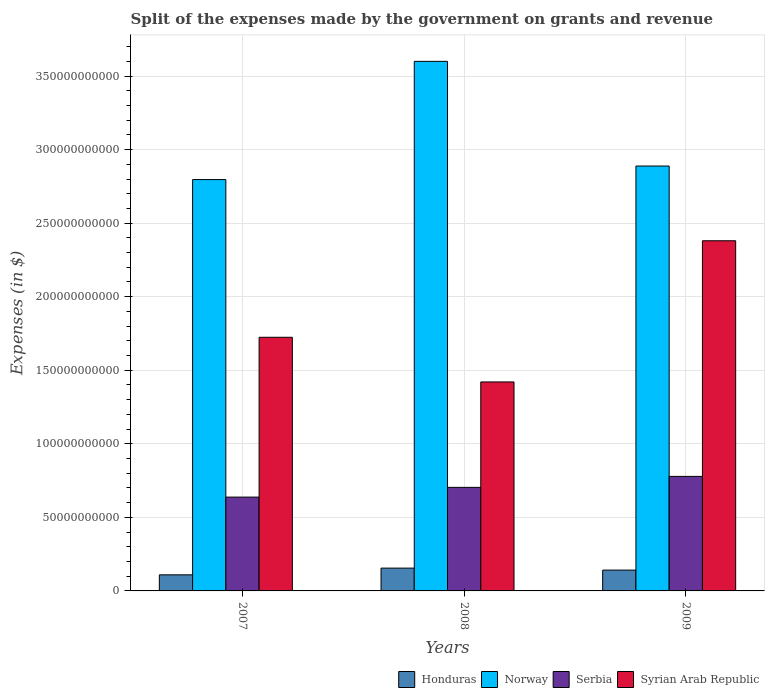How many different coloured bars are there?
Provide a short and direct response. 4. Are the number of bars per tick equal to the number of legend labels?
Give a very brief answer. Yes. Are the number of bars on each tick of the X-axis equal?
Give a very brief answer. Yes. What is the label of the 1st group of bars from the left?
Offer a very short reply. 2007. In how many cases, is the number of bars for a given year not equal to the number of legend labels?
Make the answer very short. 0. What is the expenses made by the government on grants and revenue in Serbia in 2009?
Your answer should be compact. 7.79e+1. Across all years, what is the maximum expenses made by the government on grants and revenue in Syrian Arab Republic?
Provide a short and direct response. 2.38e+11. Across all years, what is the minimum expenses made by the government on grants and revenue in Norway?
Keep it short and to the point. 2.80e+11. In which year was the expenses made by the government on grants and revenue in Serbia maximum?
Provide a succinct answer. 2009. In which year was the expenses made by the government on grants and revenue in Norway minimum?
Ensure brevity in your answer.  2007. What is the total expenses made by the government on grants and revenue in Norway in the graph?
Offer a very short reply. 9.28e+11. What is the difference between the expenses made by the government on grants and revenue in Syrian Arab Republic in 2008 and that in 2009?
Provide a succinct answer. -9.60e+1. What is the difference between the expenses made by the government on grants and revenue in Honduras in 2008 and the expenses made by the government on grants and revenue in Syrian Arab Republic in 2007?
Offer a very short reply. -1.57e+11. What is the average expenses made by the government on grants and revenue in Honduras per year?
Provide a succinct answer. 1.35e+1. In the year 2009, what is the difference between the expenses made by the government on grants and revenue in Serbia and expenses made by the government on grants and revenue in Norway?
Your response must be concise. -2.11e+11. In how many years, is the expenses made by the government on grants and revenue in Syrian Arab Republic greater than 170000000000 $?
Offer a terse response. 2. What is the ratio of the expenses made by the government on grants and revenue in Serbia in 2008 to that in 2009?
Offer a terse response. 0.9. What is the difference between the highest and the second highest expenses made by the government on grants and revenue in Syrian Arab Republic?
Your answer should be compact. 6.56e+1. What is the difference between the highest and the lowest expenses made by the government on grants and revenue in Honduras?
Offer a terse response. 4.57e+09. Is it the case that in every year, the sum of the expenses made by the government on grants and revenue in Norway and expenses made by the government on grants and revenue in Serbia is greater than the sum of expenses made by the government on grants and revenue in Syrian Arab Republic and expenses made by the government on grants and revenue in Honduras?
Offer a very short reply. No. What does the 4th bar from the left in 2009 represents?
Provide a succinct answer. Syrian Arab Republic. What does the 2nd bar from the right in 2007 represents?
Provide a short and direct response. Serbia. Is it the case that in every year, the sum of the expenses made by the government on grants and revenue in Serbia and expenses made by the government on grants and revenue in Norway is greater than the expenses made by the government on grants and revenue in Syrian Arab Republic?
Your answer should be compact. Yes. How many bars are there?
Ensure brevity in your answer.  12. Are all the bars in the graph horizontal?
Your response must be concise. No. What is the difference between two consecutive major ticks on the Y-axis?
Make the answer very short. 5.00e+1. Are the values on the major ticks of Y-axis written in scientific E-notation?
Your answer should be compact. No. Where does the legend appear in the graph?
Provide a succinct answer. Bottom right. How many legend labels are there?
Offer a terse response. 4. How are the legend labels stacked?
Keep it short and to the point. Horizontal. What is the title of the graph?
Make the answer very short. Split of the expenses made by the government on grants and revenue. What is the label or title of the X-axis?
Your answer should be very brief. Years. What is the label or title of the Y-axis?
Your answer should be very brief. Expenses (in $). What is the Expenses (in $) in Honduras in 2007?
Keep it short and to the point. 1.09e+1. What is the Expenses (in $) in Norway in 2007?
Your response must be concise. 2.80e+11. What is the Expenses (in $) of Serbia in 2007?
Your answer should be compact. 6.38e+1. What is the Expenses (in $) of Syrian Arab Republic in 2007?
Provide a succinct answer. 1.72e+11. What is the Expenses (in $) of Honduras in 2008?
Make the answer very short. 1.55e+1. What is the Expenses (in $) of Norway in 2008?
Your answer should be compact. 3.60e+11. What is the Expenses (in $) in Serbia in 2008?
Offer a very short reply. 7.04e+1. What is the Expenses (in $) in Syrian Arab Republic in 2008?
Your answer should be compact. 1.42e+11. What is the Expenses (in $) of Honduras in 2009?
Ensure brevity in your answer.  1.41e+1. What is the Expenses (in $) of Norway in 2009?
Your answer should be very brief. 2.89e+11. What is the Expenses (in $) of Serbia in 2009?
Ensure brevity in your answer.  7.79e+1. What is the Expenses (in $) of Syrian Arab Republic in 2009?
Your response must be concise. 2.38e+11. Across all years, what is the maximum Expenses (in $) of Honduras?
Your answer should be very brief. 1.55e+1. Across all years, what is the maximum Expenses (in $) in Norway?
Give a very brief answer. 3.60e+11. Across all years, what is the maximum Expenses (in $) of Serbia?
Your answer should be compact. 7.79e+1. Across all years, what is the maximum Expenses (in $) of Syrian Arab Republic?
Your answer should be very brief. 2.38e+11. Across all years, what is the minimum Expenses (in $) in Honduras?
Provide a succinct answer. 1.09e+1. Across all years, what is the minimum Expenses (in $) in Norway?
Your answer should be very brief. 2.80e+11. Across all years, what is the minimum Expenses (in $) in Serbia?
Ensure brevity in your answer.  6.38e+1. Across all years, what is the minimum Expenses (in $) of Syrian Arab Republic?
Provide a short and direct response. 1.42e+11. What is the total Expenses (in $) of Honduras in the graph?
Make the answer very short. 4.06e+1. What is the total Expenses (in $) in Norway in the graph?
Provide a short and direct response. 9.28e+11. What is the total Expenses (in $) in Serbia in the graph?
Your answer should be very brief. 2.12e+11. What is the total Expenses (in $) of Syrian Arab Republic in the graph?
Offer a very short reply. 5.52e+11. What is the difference between the Expenses (in $) of Honduras in 2007 and that in 2008?
Your answer should be very brief. -4.57e+09. What is the difference between the Expenses (in $) of Norway in 2007 and that in 2008?
Provide a succinct answer. -8.04e+1. What is the difference between the Expenses (in $) in Serbia in 2007 and that in 2008?
Give a very brief answer. -6.62e+09. What is the difference between the Expenses (in $) of Syrian Arab Republic in 2007 and that in 2008?
Offer a very short reply. 3.04e+1. What is the difference between the Expenses (in $) of Honduras in 2007 and that in 2009?
Your response must be concise. -3.22e+09. What is the difference between the Expenses (in $) of Norway in 2007 and that in 2009?
Offer a terse response. -9.20e+09. What is the difference between the Expenses (in $) in Serbia in 2007 and that in 2009?
Offer a terse response. -1.41e+1. What is the difference between the Expenses (in $) in Syrian Arab Republic in 2007 and that in 2009?
Offer a terse response. -6.56e+1. What is the difference between the Expenses (in $) of Honduras in 2008 and that in 2009?
Make the answer very short. 1.35e+09. What is the difference between the Expenses (in $) in Norway in 2008 and that in 2009?
Keep it short and to the point. 7.12e+1. What is the difference between the Expenses (in $) of Serbia in 2008 and that in 2009?
Your answer should be compact. -7.46e+09. What is the difference between the Expenses (in $) of Syrian Arab Republic in 2008 and that in 2009?
Your answer should be compact. -9.60e+1. What is the difference between the Expenses (in $) in Honduras in 2007 and the Expenses (in $) in Norway in 2008?
Your answer should be very brief. -3.49e+11. What is the difference between the Expenses (in $) of Honduras in 2007 and the Expenses (in $) of Serbia in 2008?
Provide a short and direct response. -5.95e+1. What is the difference between the Expenses (in $) in Honduras in 2007 and the Expenses (in $) in Syrian Arab Republic in 2008?
Your answer should be very brief. -1.31e+11. What is the difference between the Expenses (in $) of Norway in 2007 and the Expenses (in $) of Serbia in 2008?
Offer a terse response. 2.09e+11. What is the difference between the Expenses (in $) of Norway in 2007 and the Expenses (in $) of Syrian Arab Republic in 2008?
Keep it short and to the point. 1.38e+11. What is the difference between the Expenses (in $) of Serbia in 2007 and the Expenses (in $) of Syrian Arab Republic in 2008?
Offer a very short reply. -7.83e+1. What is the difference between the Expenses (in $) in Honduras in 2007 and the Expenses (in $) in Norway in 2009?
Offer a terse response. -2.78e+11. What is the difference between the Expenses (in $) in Honduras in 2007 and the Expenses (in $) in Serbia in 2009?
Your answer should be very brief. -6.69e+1. What is the difference between the Expenses (in $) of Honduras in 2007 and the Expenses (in $) of Syrian Arab Republic in 2009?
Your answer should be very brief. -2.27e+11. What is the difference between the Expenses (in $) of Norway in 2007 and the Expenses (in $) of Serbia in 2009?
Your answer should be compact. 2.02e+11. What is the difference between the Expenses (in $) in Norway in 2007 and the Expenses (in $) in Syrian Arab Republic in 2009?
Provide a succinct answer. 4.16e+1. What is the difference between the Expenses (in $) of Serbia in 2007 and the Expenses (in $) of Syrian Arab Republic in 2009?
Give a very brief answer. -1.74e+11. What is the difference between the Expenses (in $) of Honduras in 2008 and the Expenses (in $) of Norway in 2009?
Make the answer very short. -2.73e+11. What is the difference between the Expenses (in $) of Honduras in 2008 and the Expenses (in $) of Serbia in 2009?
Provide a succinct answer. -6.24e+1. What is the difference between the Expenses (in $) in Honduras in 2008 and the Expenses (in $) in Syrian Arab Republic in 2009?
Keep it short and to the point. -2.23e+11. What is the difference between the Expenses (in $) of Norway in 2008 and the Expenses (in $) of Serbia in 2009?
Provide a short and direct response. 2.82e+11. What is the difference between the Expenses (in $) of Norway in 2008 and the Expenses (in $) of Syrian Arab Republic in 2009?
Keep it short and to the point. 1.22e+11. What is the difference between the Expenses (in $) of Serbia in 2008 and the Expenses (in $) of Syrian Arab Republic in 2009?
Keep it short and to the point. -1.68e+11. What is the average Expenses (in $) in Honduras per year?
Provide a short and direct response. 1.35e+1. What is the average Expenses (in $) in Norway per year?
Your answer should be compact. 3.09e+11. What is the average Expenses (in $) in Serbia per year?
Your answer should be compact. 7.07e+1. What is the average Expenses (in $) of Syrian Arab Republic per year?
Give a very brief answer. 1.84e+11. In the year 2007, what is the difference between the Expenses (in $) in Honduras and Expenses (in $) in Norway?
Provide a short and direct response. -2.69e+11. In the year 2007, what is the difference between the Expenses (in $) of Honduras and Expenses (in $) of Serbia?
Make the answer very short. -5.28e+1. In the year 2007, what is the difference between the Expenses (in $) in Honduras and Expenses (in $) in Syrian Arab Republic?
Offer a terse response. -1.61e+11. In the year 2007, what is the difference between the Expenses (in $) of Norway and Expenses (in $) of Serbia?
Give a very brief answer. 2.16e+11. In the year 2007, what is the difference between the Expenses (in $) in Norway and Expenses (in $) in Syrian Arab Republic?
Keep it short and to the point. 1.07e+11. In the year 2007, what is the difference between the Expenses (in $) in Serbia and Expenses (in $) in Syrian Arab Republic?
Ensure brevity in your answer.  -1.09e+11. In the year 2008, what is the difference between the Expenses (in $) in Honduras and Expenses (in $) in Norway?
Your answer should be very brief. -3.44e+11. In the year 2008, what is the difference between the Expenses (in $) in Honduras and Expenses (in $) in Serbia?
Make the answer very short. -5.49e+1. In the year 2008, what is the difference between the Expenses (in $) of Honduras and Expenses (in $) of Syrian Arab Republic?
Offer a terse response. -1.27e+11. In the year 2008, what is the difference between the Expenses (in $) of Norway and Expenses (in $) of Serbia?
Your answer should be compact. 2.90e+11. In the year 2008, what is the difference between the Expenses (in $) in Norway and Expenses (in $) in Syrian Arab Republic?
Keep it short and to the point. 2.18e+11. In the year 2008, what is the difference between the Expenses (in $) in Serbia and Expenses (in $) in Syrian Arab Republic?
Provide a short and direct response. -7.17e+1. In the year 2009, what is the difference between the Expenses (in $) of Honduras and Expenses (in $) of Norway?
Provide a short and direct response. -2.75e+11. In the year 2009, what is the difference between the Expenses (in $) in Honduras and Expenses (in $) in Serbia?
Provide a short and direct response. -6.37e+1. In the year 2009, what is the difference between the Expenses (in $) of Honduras and Expenses (in $) of Syrian Arab Republic?
Your response must be concise. -2.24e+11. In the year 2009, what is the difference between the Expenses (in $) in Norway and Expenses (in $) in Serbia?
Make the answer very short. 2.11e+11. In the year 2009, what is the difference between the Expenses (in $) in Norway and Expenses (in $) in Syrian Arab Republic?
Provide a short and direct response. 5.08e+1. In the year 2009, what is the difference between the Expenses (in $) of Serbia and Expenses (in $) of Syrian Arab Republic?
Your response must be concise. -1.60e+11. What is the ratio of the Expenses (in $) of Honduras in 2007 to that in 2008?
Your answer should be compact. 0.71. What is the ratio of the Expenses (in $) in Norway in 2007 to that in 2008?
Your response must be concise. 0.78. What is the ratio of the Expenses (in $) in Serbia in 2007 to that in 2008?
Your answer should be compact. 0.91. What is the ratio of the Expenses (in $) of Syrian Arab Republic in 2007 to that in 2008?
Provide a short and direct response. 1.21. What is the ratio of the Expenses (in $) in Honduras in 2007 to that in 2009?
Ensure brevity in your answer.  0.77. What is the ratio of the Expenses (in $) in Norway in 2007 to that in 2009?
Keep it short and to the point. 0.97. What is the ratio of the Expenses (in $) of Serbia in 2007 to that in 2009?
Ensure brevity in your answer.  0.82. What is the ratio of the Expenses (in $) in Syrian Arab Republic in 2007 to that in 2009?
Provide a short and direct response. 0.72. What is the ratio of the Expenses (in $) in Honduras in 2008 to that in 2009?
Make the answer very short. 1.1. What is the ratio of the Expenses (in $) of Norway in 2008 to that in 2009?
Ensure brevity in your answer.  1.25. What is the ratio of the Expenses (in $) in Serbia in 2008 to that in 2009?
Your answer should be compact. 0.9. What is the ratio of the Expenses (in $) in Syrian Arab Republic in 2008 to that in 2009?
Your response must be concise. 0.6. What is the difference between the highest and the second highest Expenses (in $) of Honduras?
Keep it short and to the point. 1.35e+09. What is the difference between the highest and the second highest Expenses (in $) of Norway?
Provide a succinct answer. 7.12e+1. What is the difference between the highest and the second highest Expenses (in $) of Serbia?
Your answer should be compact. 7.46e+09. What is the difference between the highest and the second highest Expenses (in $) of Syrian Arab Republic?
Offer a very short reply. 6.56e+1. What is the difference between the highest and the lowest Expenses (in $) in Honduras?
Your response must be concise. 4.57e+09. What is the difference between the highest and the lowest Expenses (in $) in Norway?
Your answer should be very brief. 8.04e+1. What is the difference between the highest and the lowest Expenses (in $) of Serbia?
Your answer should be very brief. 1.41e+1. What is the difference between the highest and the lowest Expenses (in $) of Syrian Arab Republic?
Your answer should be compact. 9.60e+1. 